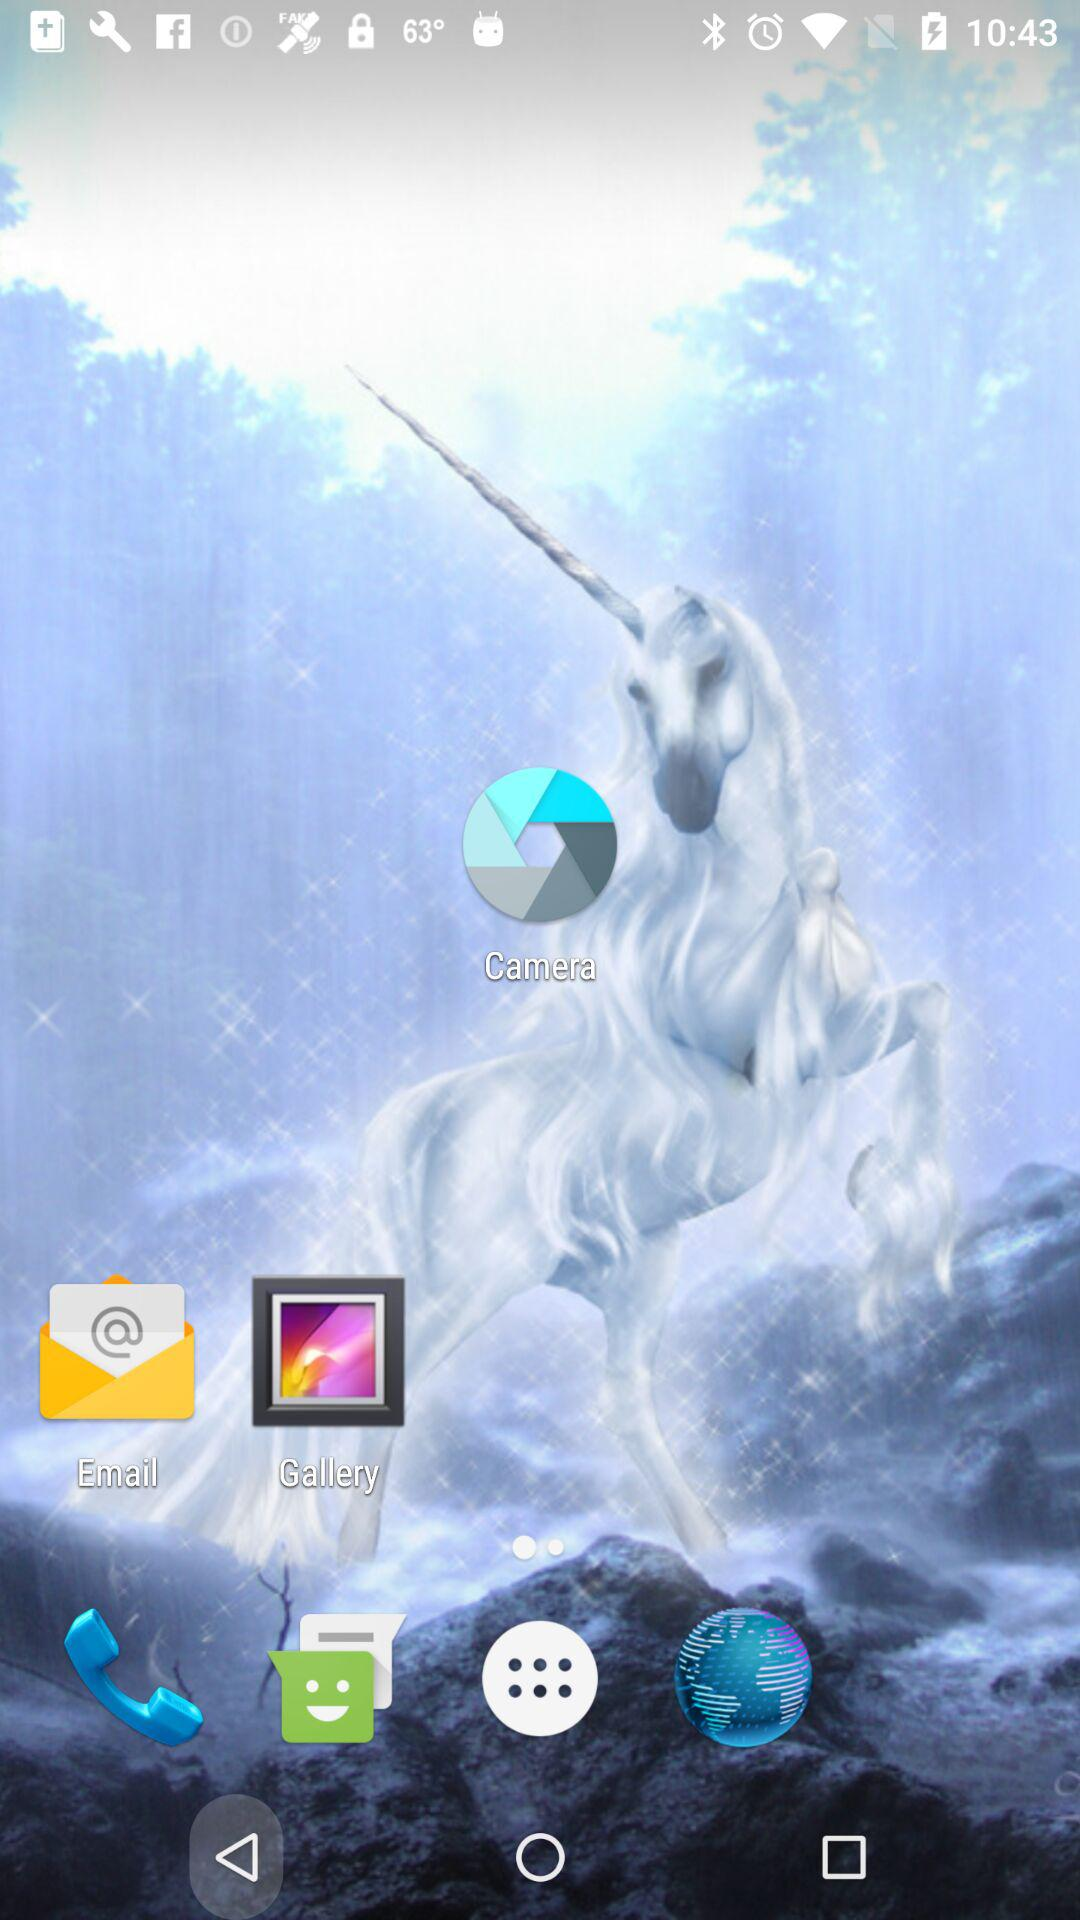How many steps are there in the process of resetting the service warning?
Answer the question using a single word or phrase. 3 